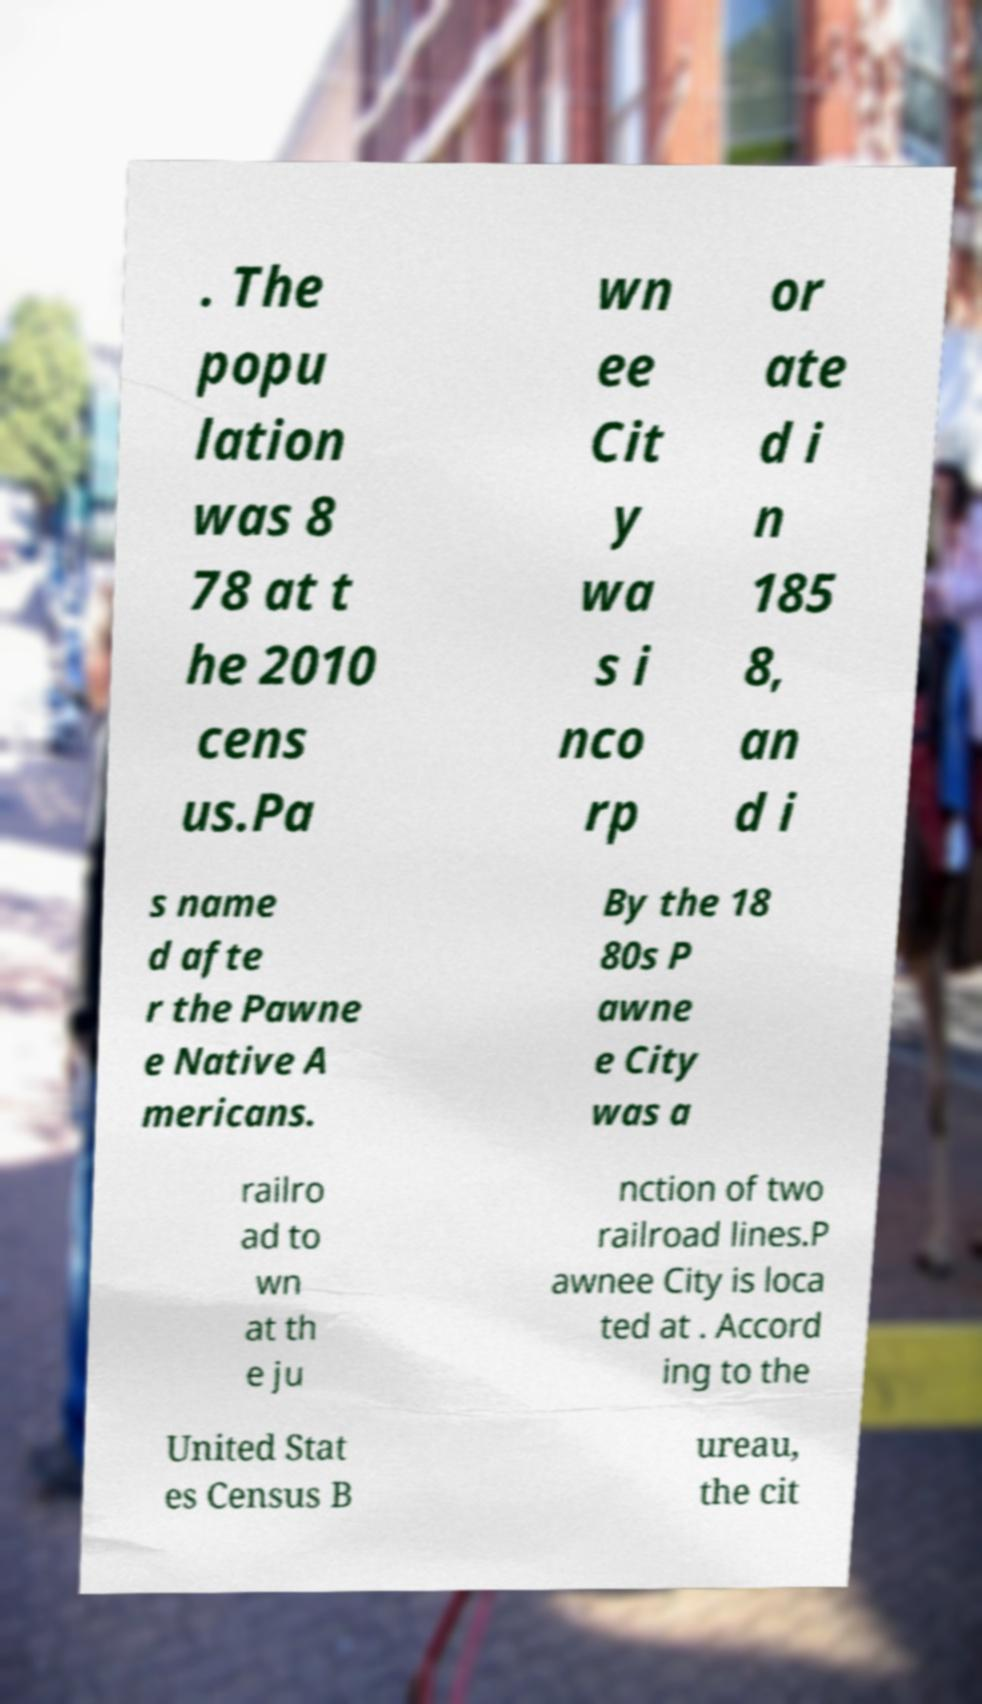Can you read and provide the text displayed in the image?This photo seems to have some interesting text. Can you extract and type it out for me? . The popu lation was 8 78 at t he 2010 cens us.Pa wn ee Cit y wa s i nco rp or ate d i n 185 8, an d i s name d afte r the Pawne e Native A mericans. By the 18 80s P awne e City was a railro ad to wn at th e ju nction of two railroad lines.P awnee City is loca ted at . Accord ing to the United Stat es Census B ureau, the cit 